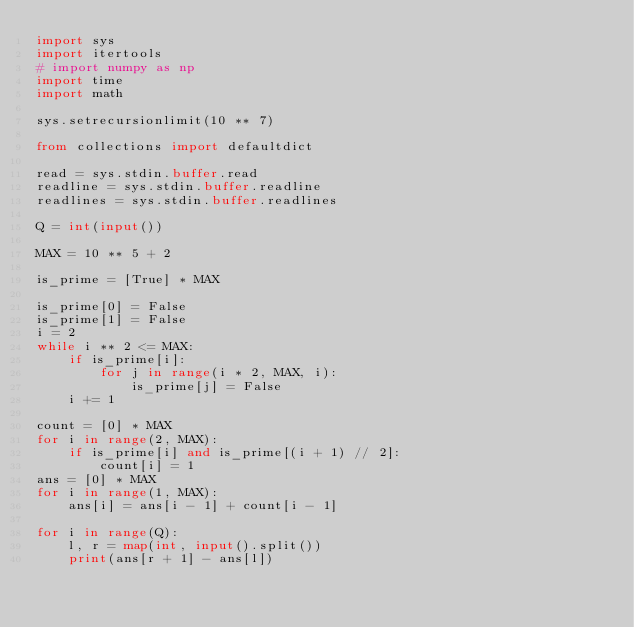Convert code to text. <code><loc_0><loc_0><loc_500><loc_500><_Python_>import sys
import itertools
# import numpy as np
import time
import math
 
sys.setrecursionlimit(10 ** 7)
 
from collections import defaultdict
 
read = sys.stdin.buffer.read
readline = sys.stdin.buffer.readline
readlines = sys.stdin.buffer.readlines

Q = int(input())

MAX = 10 ** 5 + 2

is_prime = [True] * MAX

is_prime[0] = False
is_prime[1] = False
i = 2
while i ** 2 <= MAX:
    if is_prime[i]:
        for j in range(i * 2, MAX, i):
            is_prime[j] = False
    i += 1

count = [0] * MAX
for i in range(2, MAX):
    if is_prime[i] and is_prime[(i + 1) // 2]:
        count[i] = 1
ans = [0] * MAX
for i in range(1, MAX):
    ans[i] = ans[i - 1] + count[i - 1]

for i in range(Q):
    l, r = map(int, input().split())
    print(ans[r + 1] - ans[l])
</code> 